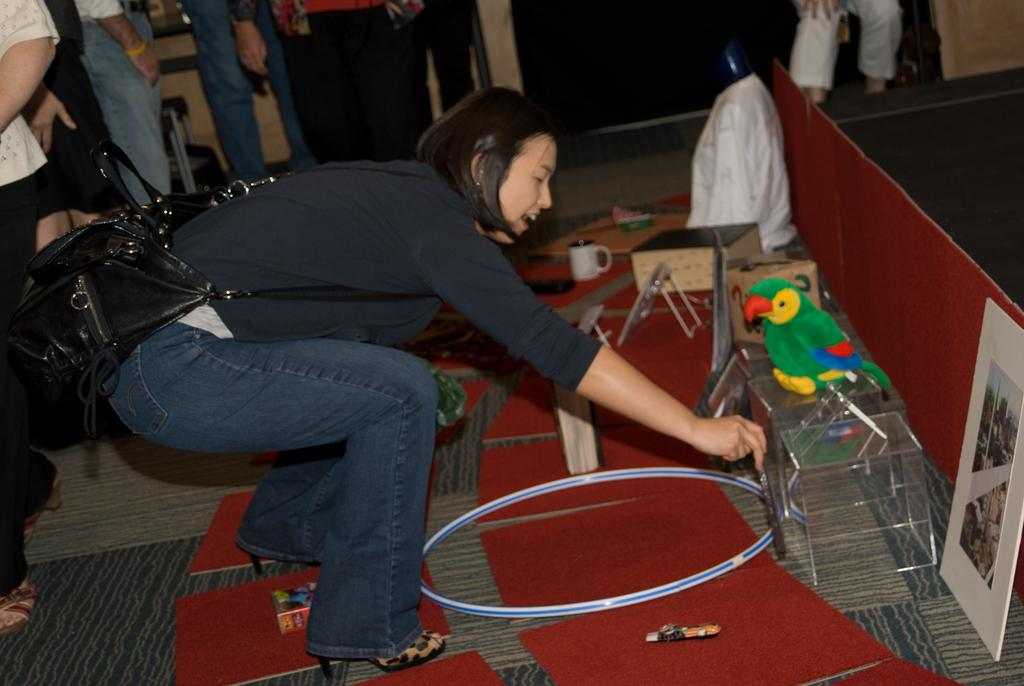What is the main subject of the image? There is a woman in the image. What is the woman wearing? The woman is wearing a bag. Are there other people in the image besides the woman? Yes, there are people standing in the image. What type of object can be seen in the image that might be used for holding or displaying items? There is a frame in the image. What is a small container for holding liquids that can be seen in the image? There is a cup in the image. What is a circular object made of metal in the image? There is a circular ring in the image. What type of objects can be seen in the image that are typically used for play? There are playing toys in the image. Are there any other objects in the image besides the ones mentioned? Yes, there are other objects in the image. Reasoning: Let' Let's think step by step in order to produce the conversation. We start by identifying the main subject of the image, which is the woman. Then, we describe what she is wearing and mention the presence of other people in the image. Next, we identify specific objects in the image, such as the frame, cup, and circular ring. We also mention the playing toys and other objects present. Each question is designed to elicit a specific detail about the image that is known from the provided facts. Absurd Question/Answer: What type of metal is the trail made of in the image? There is no trail present in the image. 